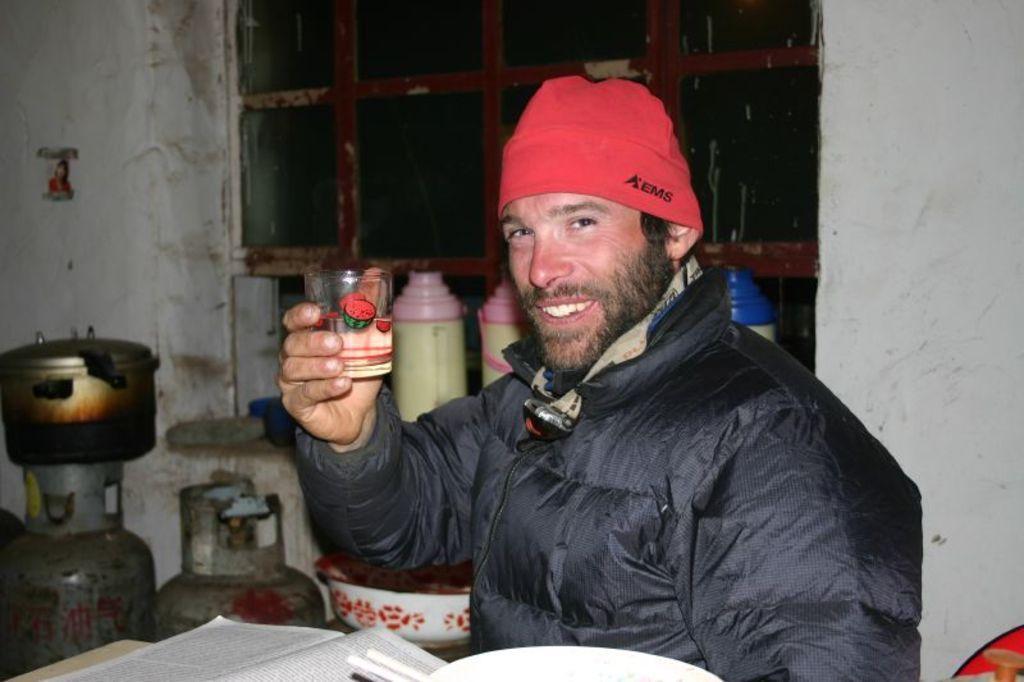In one or two sentences, can you explain what this image depicts? In this image I can see the person wearing the black color jacket and red color cap and holding the glass. To the side there is a book on the table. In the background I can see the cylinders, cooker and the bottles. I can also see the window in the back. 